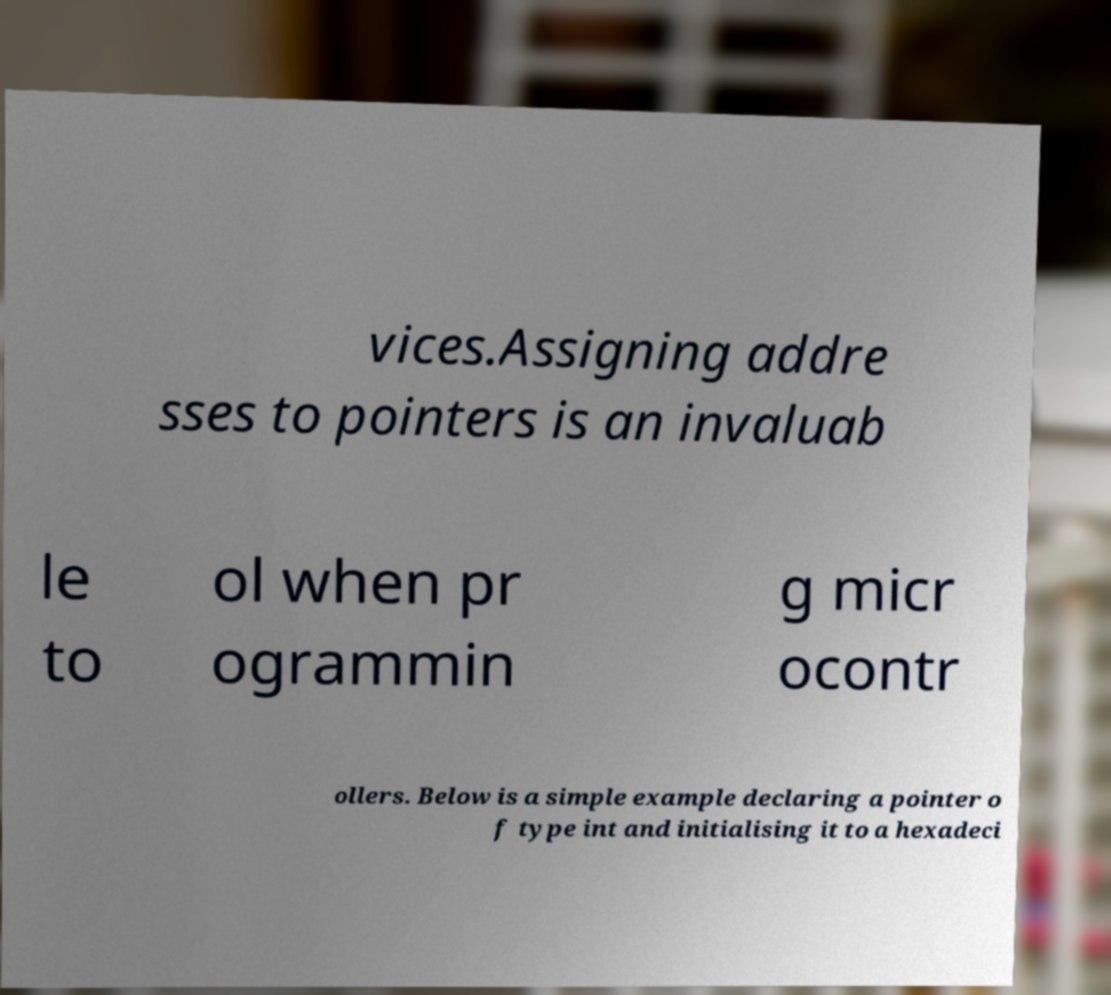What messages or text are displayed in this image? I need them in a readable, typed format. vices.Assigning addre sses to pointers is an invaluab le to ol when pr ogrammin g micr ocontr ollers. Below is a simple example declaring a pointer o f type int and initialising it to a hexadeci 